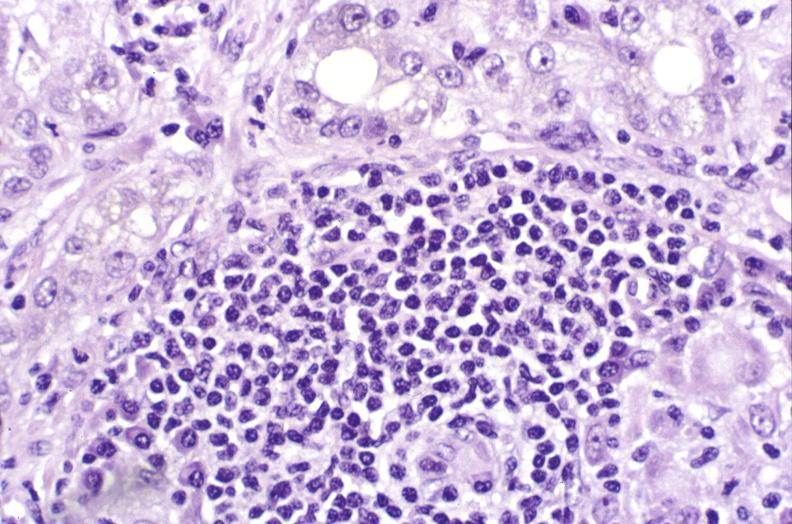what is present?
Answer the question using a single word or phrase. Hepatobiliary 